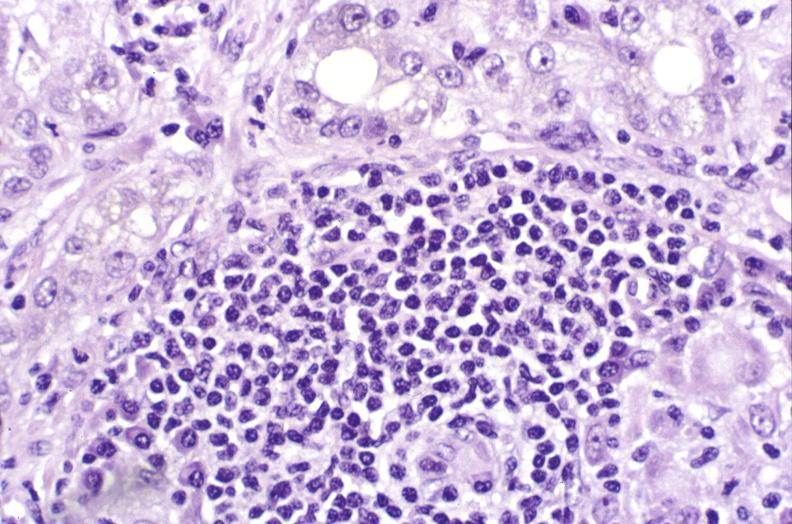what is present?
Answer the question using a single word or phrase. Hepatobiliary 